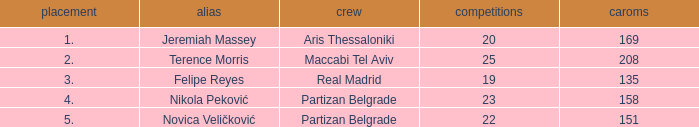Could you parse the entire table? {'header': ['placement', 'alias', 'crew', 'competitions', 'caroms'], 'rows': [['1.', 'Jeremiah Massey', 'Aris Thessaloniki', '20', '169'], ['2.', 'Terence Morris', 'Maccabi Tel Aviv', '25', '208'], ['3.', 'Felipe Reyes', 'Real Madrid', '19', '135'], ['4.', 'Nikola Peković', 'Partizan Belgrade', '23', '158'], ['5.', 'Novica Veličković', 'Partizan Belgrade', '22', '151']]} What is the number of Games for Partizan Belgrade player Nikola Peković with a Rank of more than 4? None. 